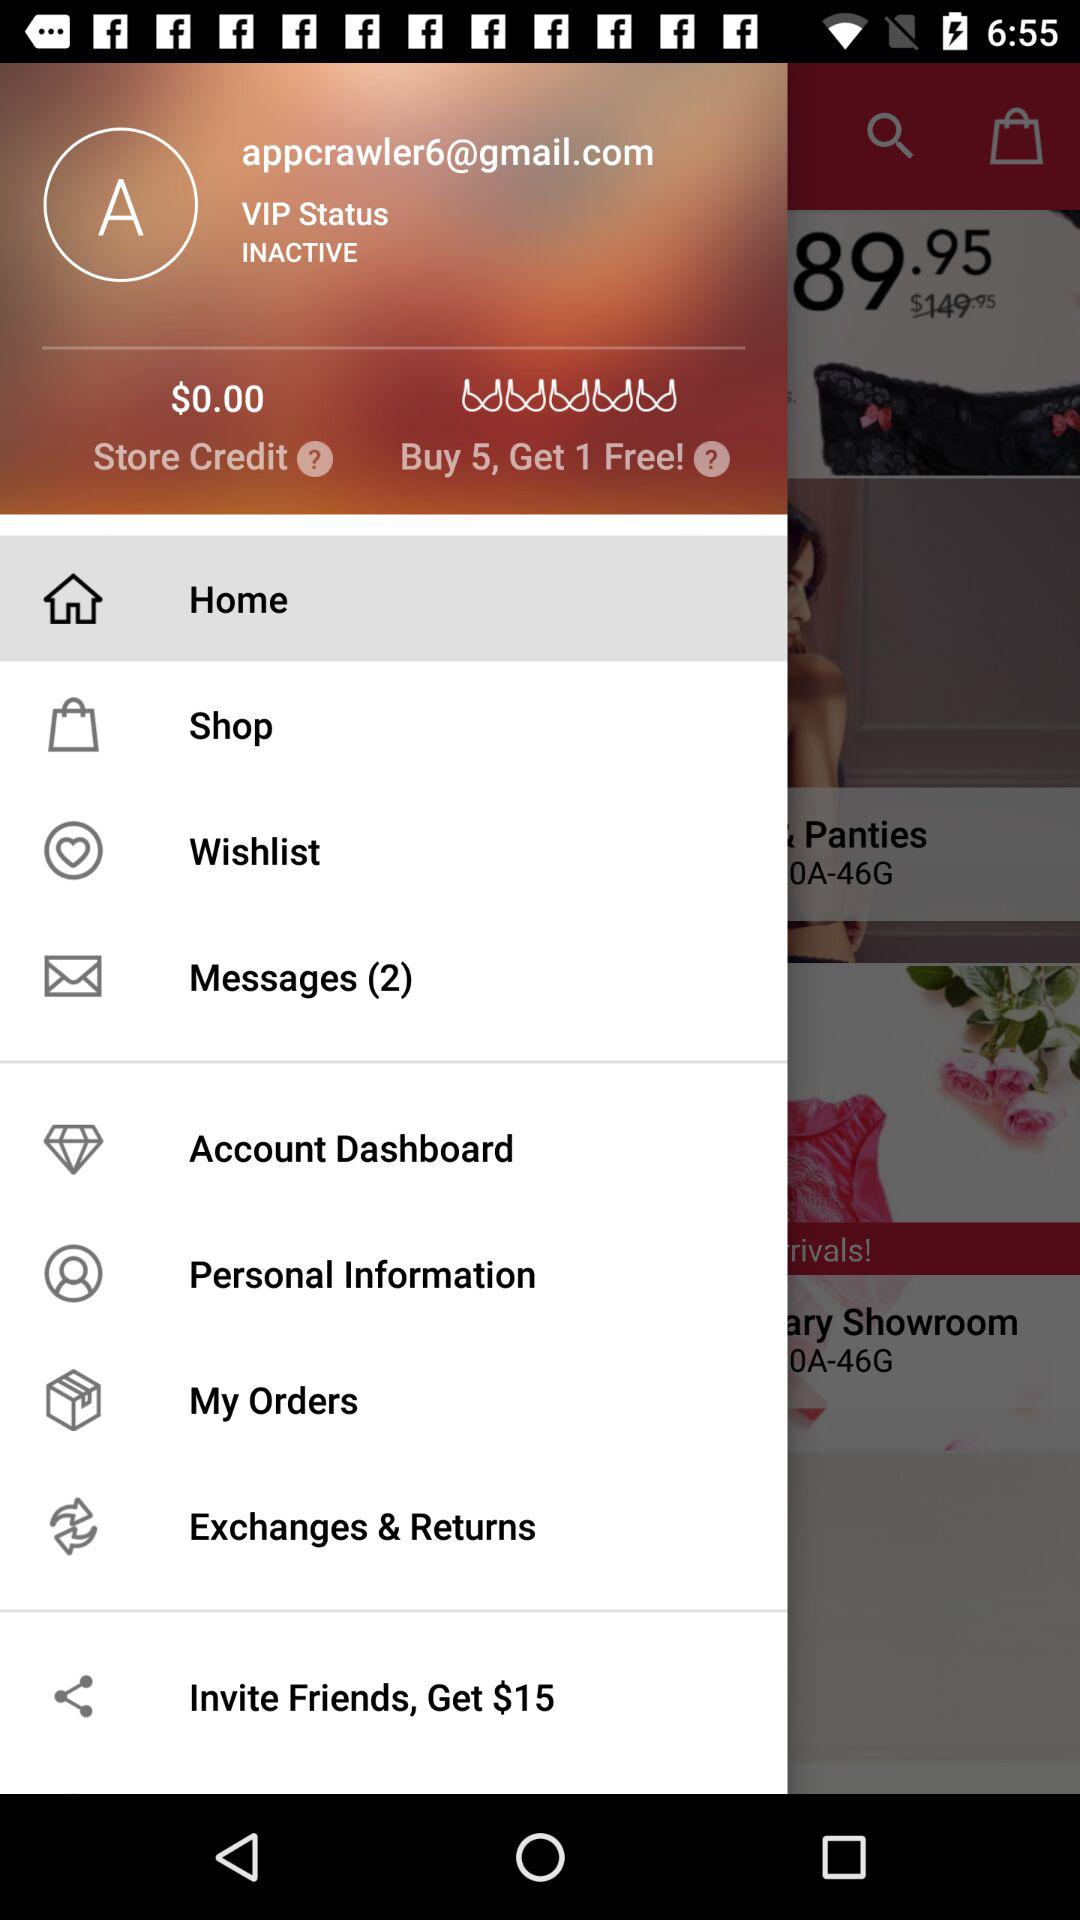What is the VIP status? VIP status is "INACTIVE". 